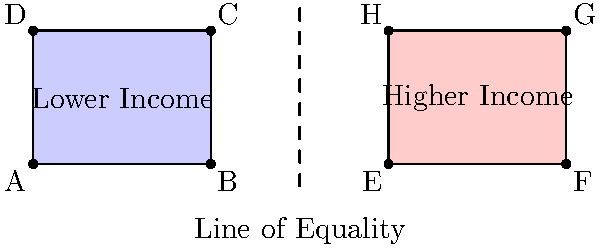The diagram represents socioeconomic disparity, with the blue rectangle representing lower income and the red rectangle representing higher income. If we reflect the blue rectangle (ABCD) across the line of equality, what will be the coordinates of point C after reflection? To find the coordinates of point C after reflection across the line of equality, we follow these steps:

1. Identify the original coordinates of point C: $(4,3)$

2. Determine the equation of the line of equality:
   The line of equality is at $x=6$

3. Calculate the distance from point C to the line of equality:
   Distance = $6 - 4 = 2$

4. Reflect point C across the line:
   - The x-coordinate will be the same distance from the line on the other side:
     New x = $6 + 2 = 8$
   - The y-coordinate remains unchanged: $y = 3$

5. Therefore, the new coordinates of point C after reflection are $(8,3)$

This reflection symbolizes equalizing the socioeconomic disparity, placing the formerly "lower income" point at the same position as the "higher income" rectangle.
Answer: $(8,3)$ 